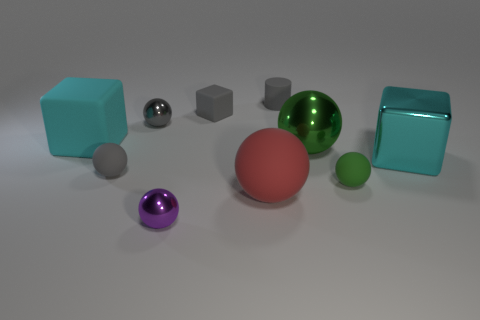What is the shape of the tiny green thing that is on the right side of the tiny rubber cylinder?
Provide a short and direct response. Sphere. Is there another brown matte cylinder of the same size as the matte cylinder?
Your answer should be compact. No. There is a purple thing that is the same size as the cylinder; what is it made of?
Your response must be concise. Metal. There is a rubber thing in front of the green rubber ball; what is its size?
Offer a very short reply. Large. What size is the purple shiny thing?
Ensure brevity in your answer.  Small. There is a purple metal object; is its size the same as the cyan thing to the right of the small green matte thing?
Give a very brief answer. No. There is a tiny rubber sphere to the right of the gray rubber object on the right side of the large red thing; what is its color?
Make the answer very short. Green. Are there the same number of small gray metal objects that are right of the gray block and large cyan matte cubes that are in front of the green metallic sphere?
Provide a succinct answer. Yes. Does the big cyan thing on the right side of the tiny gray block have the same material as the red sphere?
Offer a terse response. No. What color is the small object that is right of the tiny gray rubber cube and in front of the tiny gray rubber cylinder?
Offer a terse response. Green. 